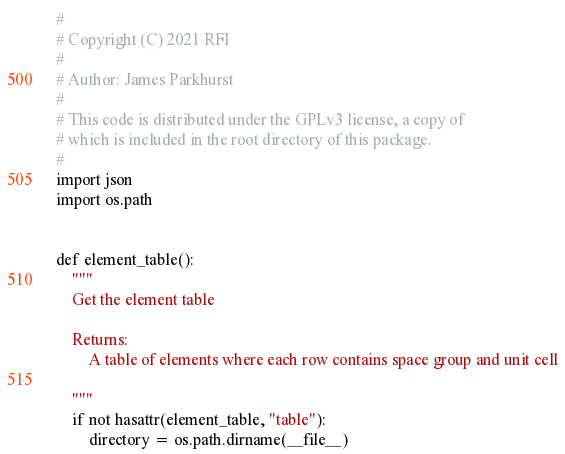<code> <loc_0><loc_0><loc_500><loc_500><_Python_>#
# Copyright (C) 2021 RFI
#
# Author: James Parkhurst
#
# This code is distributed under the GPLv3 license, a copy of
# which is included in the root directory of this package.
#
import json
import os.path


def element_table():
    """
    Get the element table

    Returns:
        A table of elements where each row contains space group and unit cell

    """
    if not hasattr(element_table, "table"):
        directory = os.path.dirname(__file__)</code> 